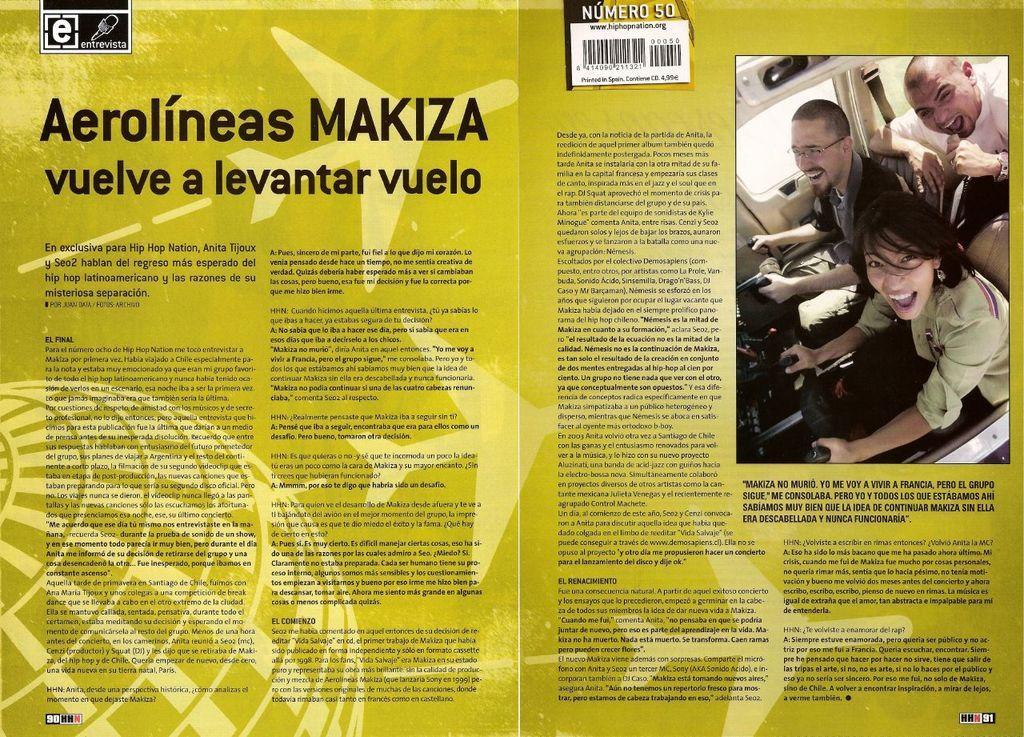Could you give a brief overview of what you see in this image? In this image we can see page of a book. Right side of the page, image is there. Top of the image bar code is present and we can see text written on the page. 